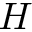<formula> <loc_0><loc_0><loc_500><loc_500>H</formula> 